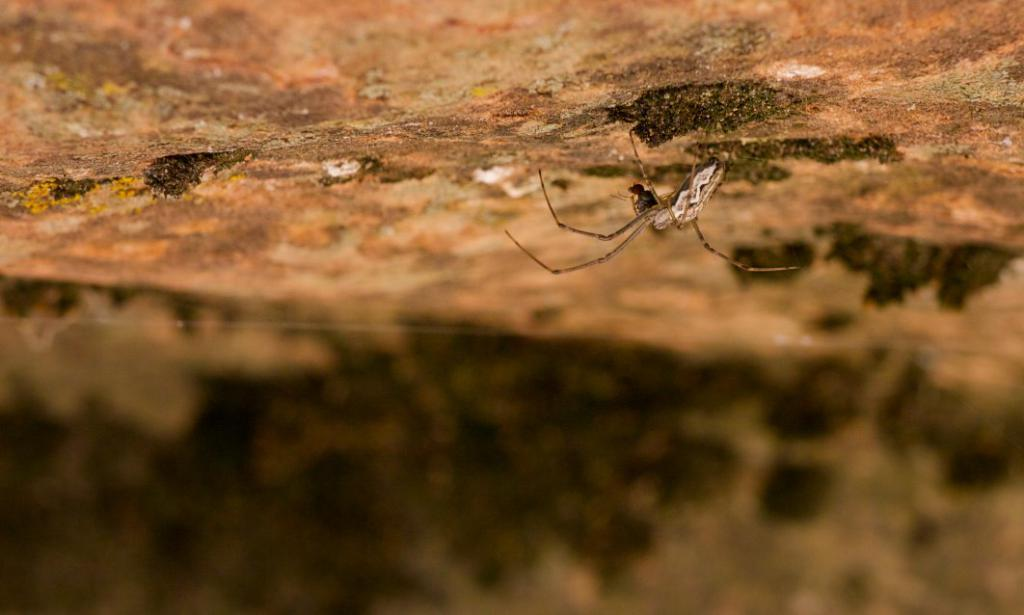What type of creature can be seen on the ground in the image? There is an insect on the ground in the image. What color is the crayon being used by the insect in the image? There is no crayon present in the image, as it features an insect on the ground. 